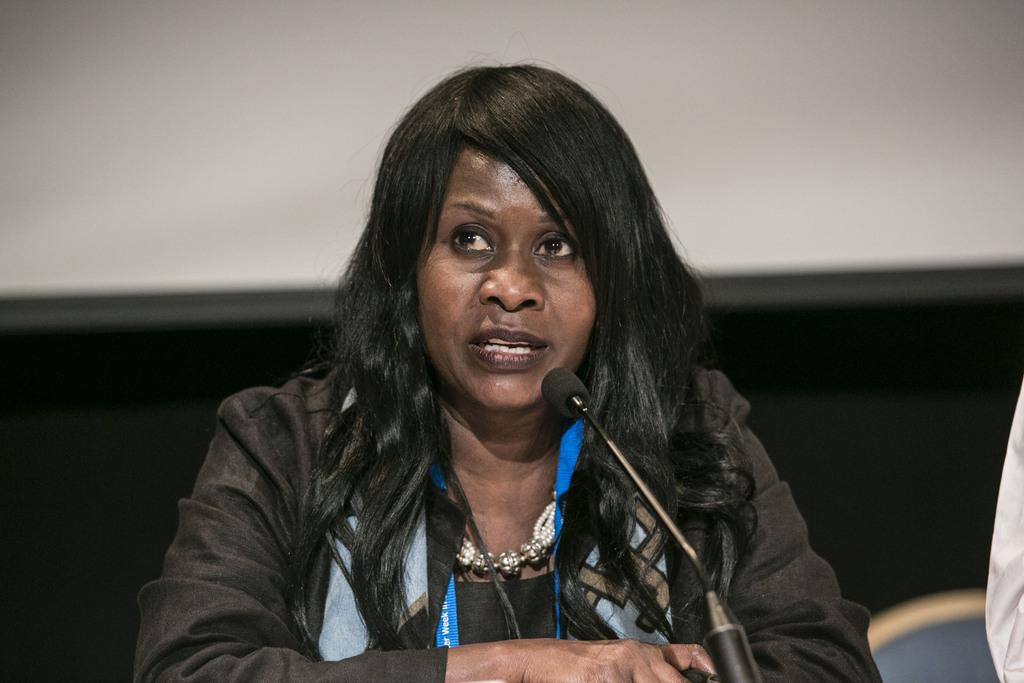What is the person in the image doing? The person is sitting in the image. What object is the person in front of? The person is in front of a microphone. What color is the dress the person is wearing? The person is wearing a black dress. What can be seen behind the person in the image? There is a white wall in the background of the image. How many waves can be seen crashing on the shore in the image? There are no waves or shore visible in the image; it features a person sitting in front of a microphone. What type of worm is crawling on the white wall in the image? There is no worm present in the image. 